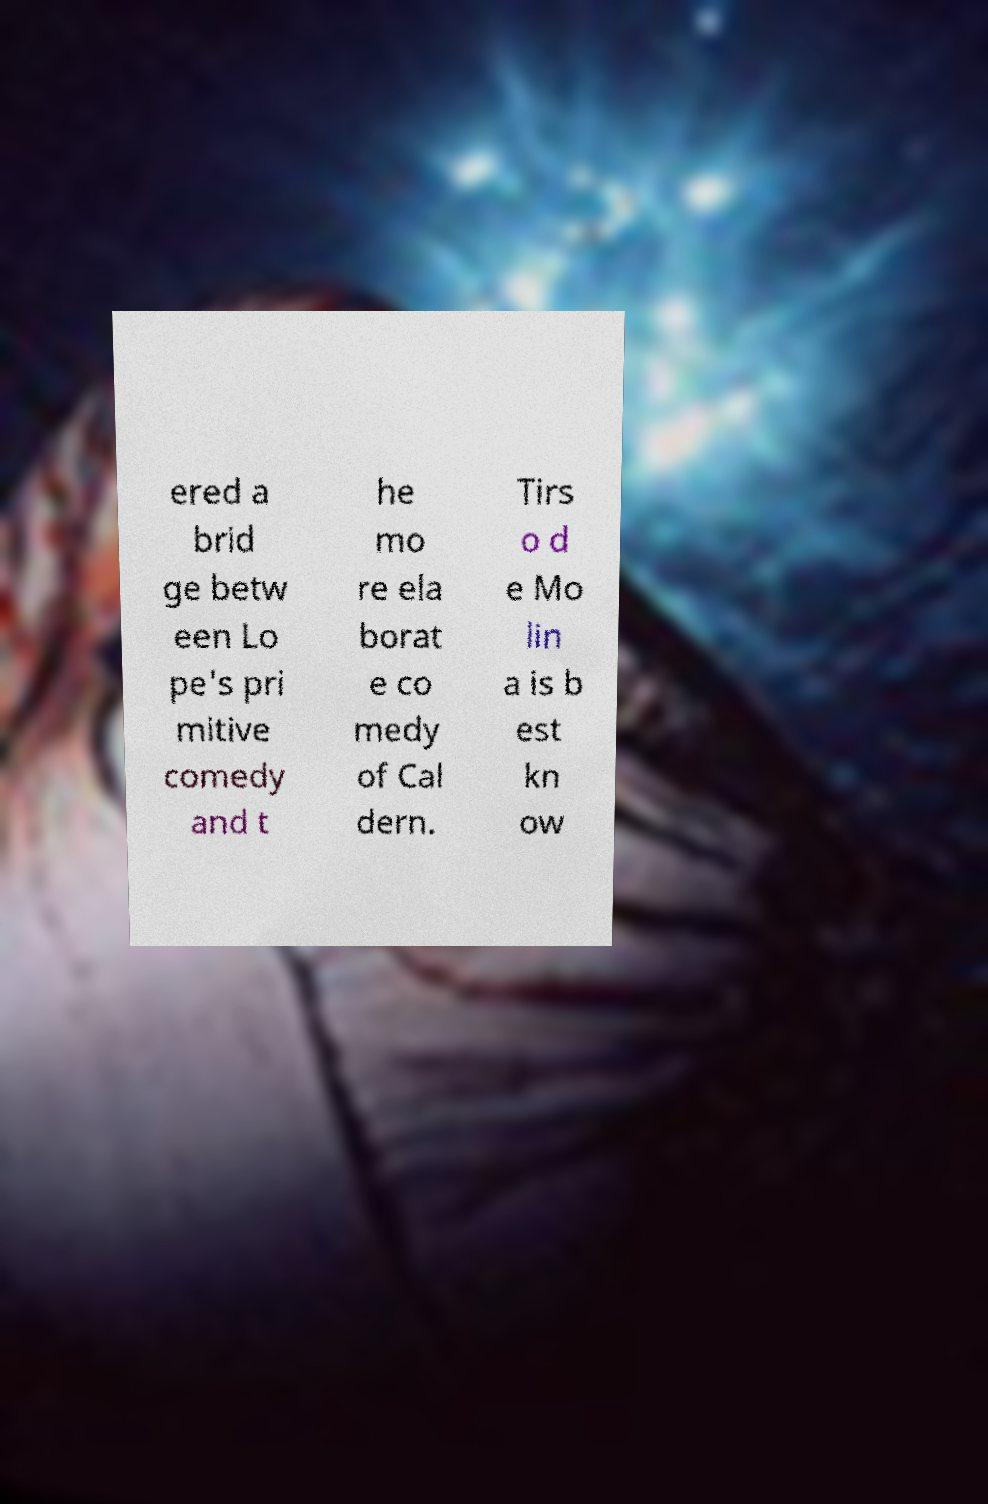Could you assist in decoding the text presented in this image and type it out clearly? ered a brid ge betw een Lo pe's pri mitive comedy and t he mo re ela borat e co medy of Cal dern. Tirs o d e Mo lin a is b est kn ow 